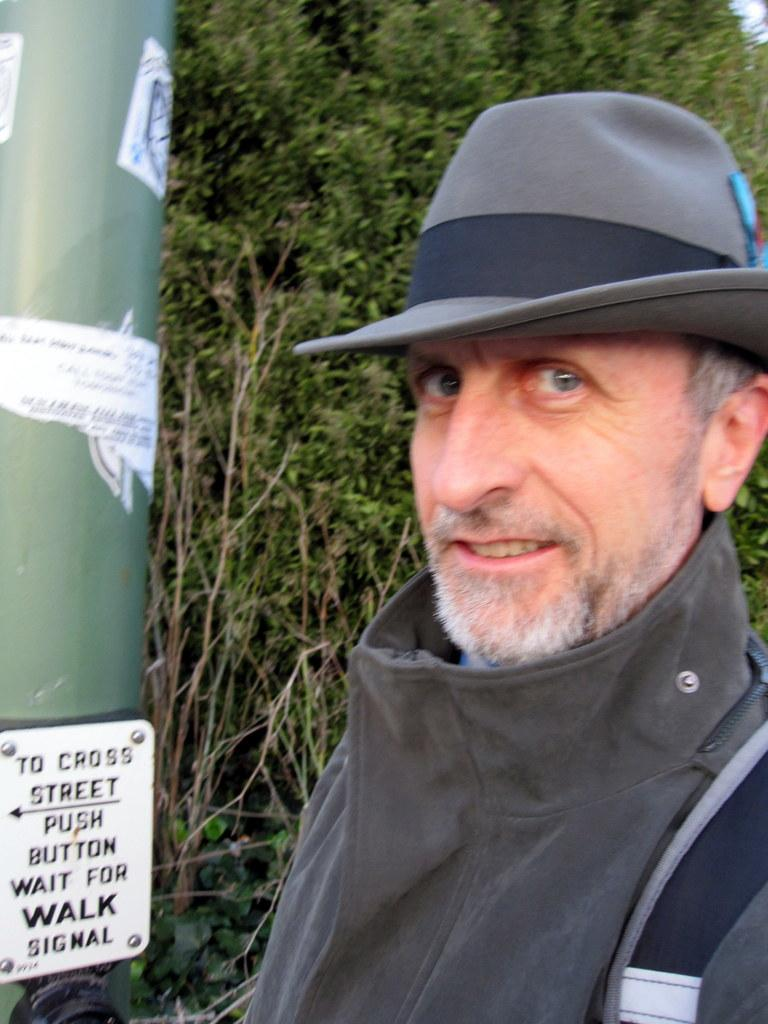Who is present in the image? There is a man in the image. Where is the man located in the image? The man is on the right side of the image. What is the man wearing on his head? The man is wearing a hat. What can be seen on the left side of the image? There is a pole in the image. What is attached to the pole? There is a board on the pole. What can be seen in the background of the image? Plants are visible in the background of the image. How many pencils are visible in the image? There are no pencils visible in the image. What type of ducks can be seen swimming in the background of the image? There are no ducks present in the image. 